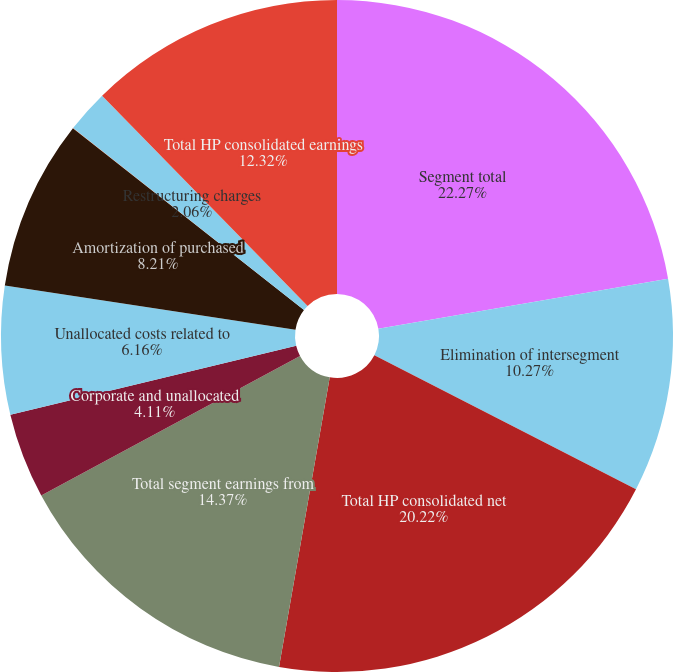Convert chart to OTSL. <chart><loc_0><loc_0><loc_500><loc_500><pie_chart><fcel>Segment total<fcel>Elimination of intersegment<fcel>Total HP consolidated net<fcel>Total segment earnings from<fcel>Corporate and unallocated<fcel>Unallocated costs related to<fcel>Amortization of purchased<fcel>Acquisition-related charges<fcel>Restructuring charges<fcel>Total HP consolidated earnings<nl><fcel>22.27%<fcel>10.27%<fcel>20.22%<fcel>14.37%<fcel>4.11%<fcel>6.16%<fcel>8.21%<fcel>0.01%<fcel>2.06%<fcel>12.32%<nl></chart> 